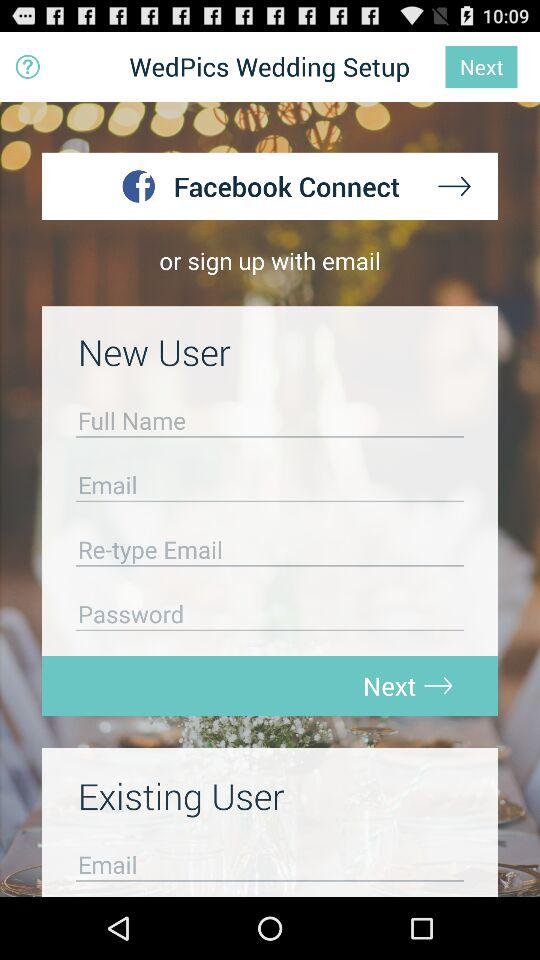How many text inputs are there for new users?
Answer the question using a single word or phrase. 4 